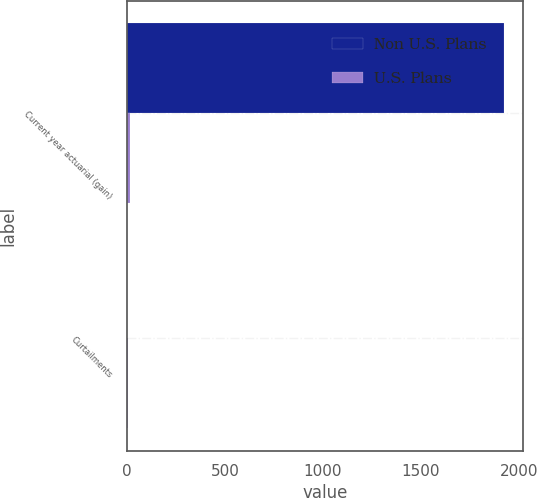Convert chart to OTSL. <chart><loc_0><loc_0><loc_500><loc_500><stacked_bar_chart><ecel><fcel>Current year actuarial (gain)<fcel>Curtailments<nl><fcel>Non U.S. Plans<fcel>1924<fcel>1<nl><fcel>U.S. Plans<fcel>13<fcel>4<nl></chart> 